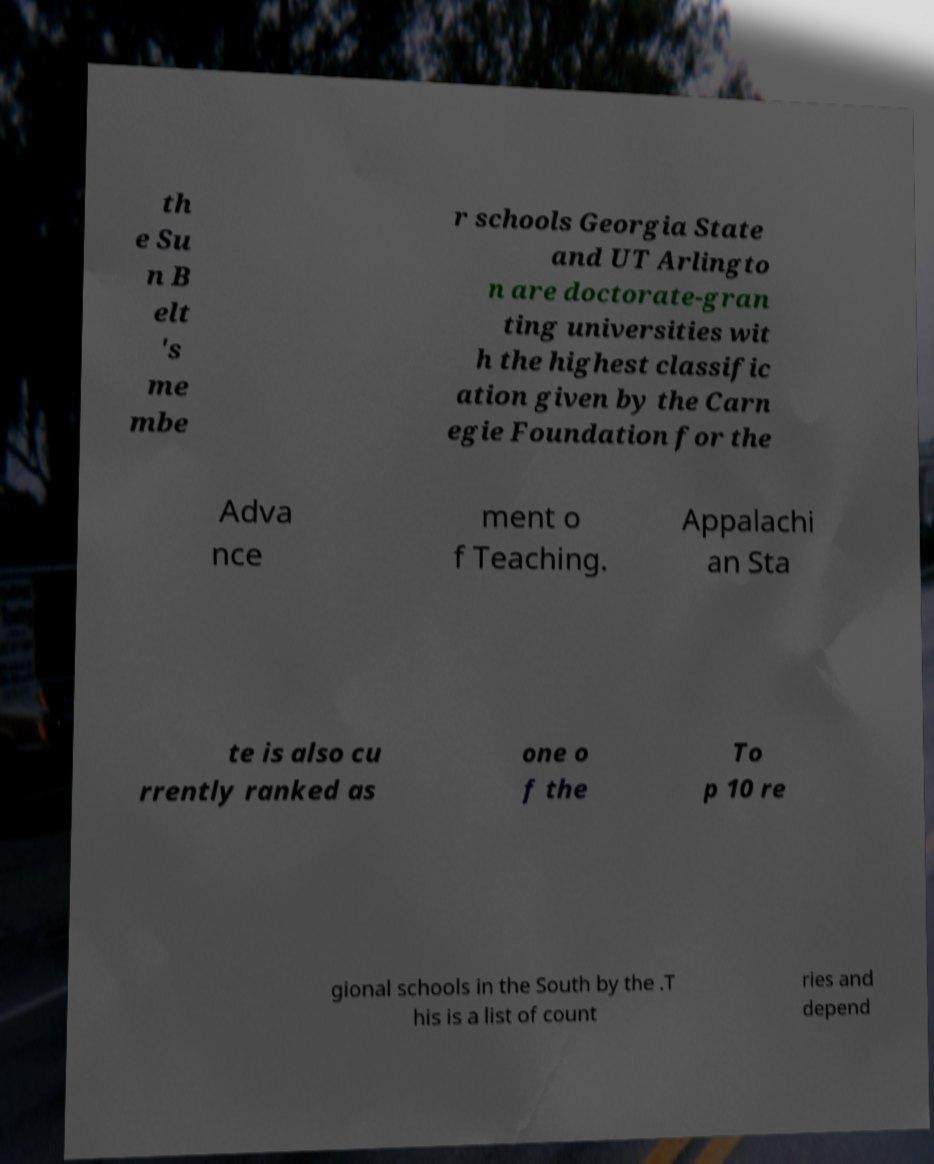Can you accurately transcribe the text from the provided image for me? th e Su n B elt 's me mbe r schools Georgia State and UT Arlingto n are doctorate-gran ting universities wit h the highest classific ation given by the Carn egie Foundation for the Adva nce ment o f Teaching. Appalachi an Sta te is also cu rrently ranked as one o f the To p 10 re gional schools in the South by the .T his is a list of count ries and depend 